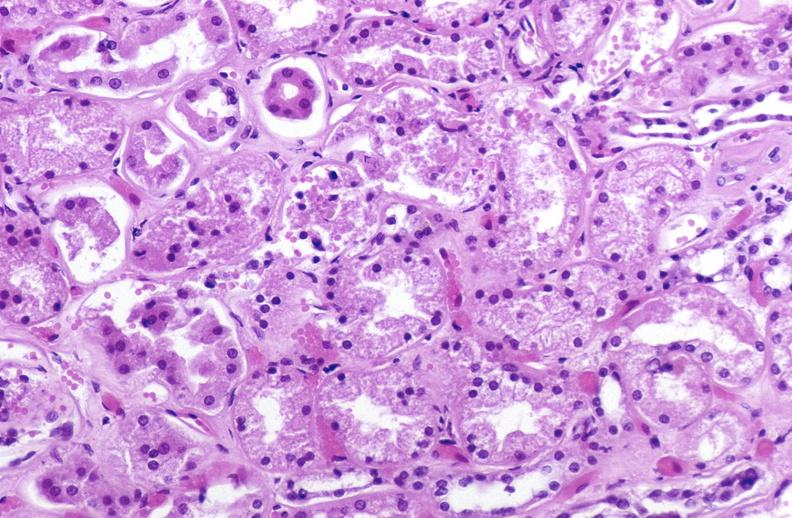where is this?
Answer the question using a single word or phrase. Urinary 